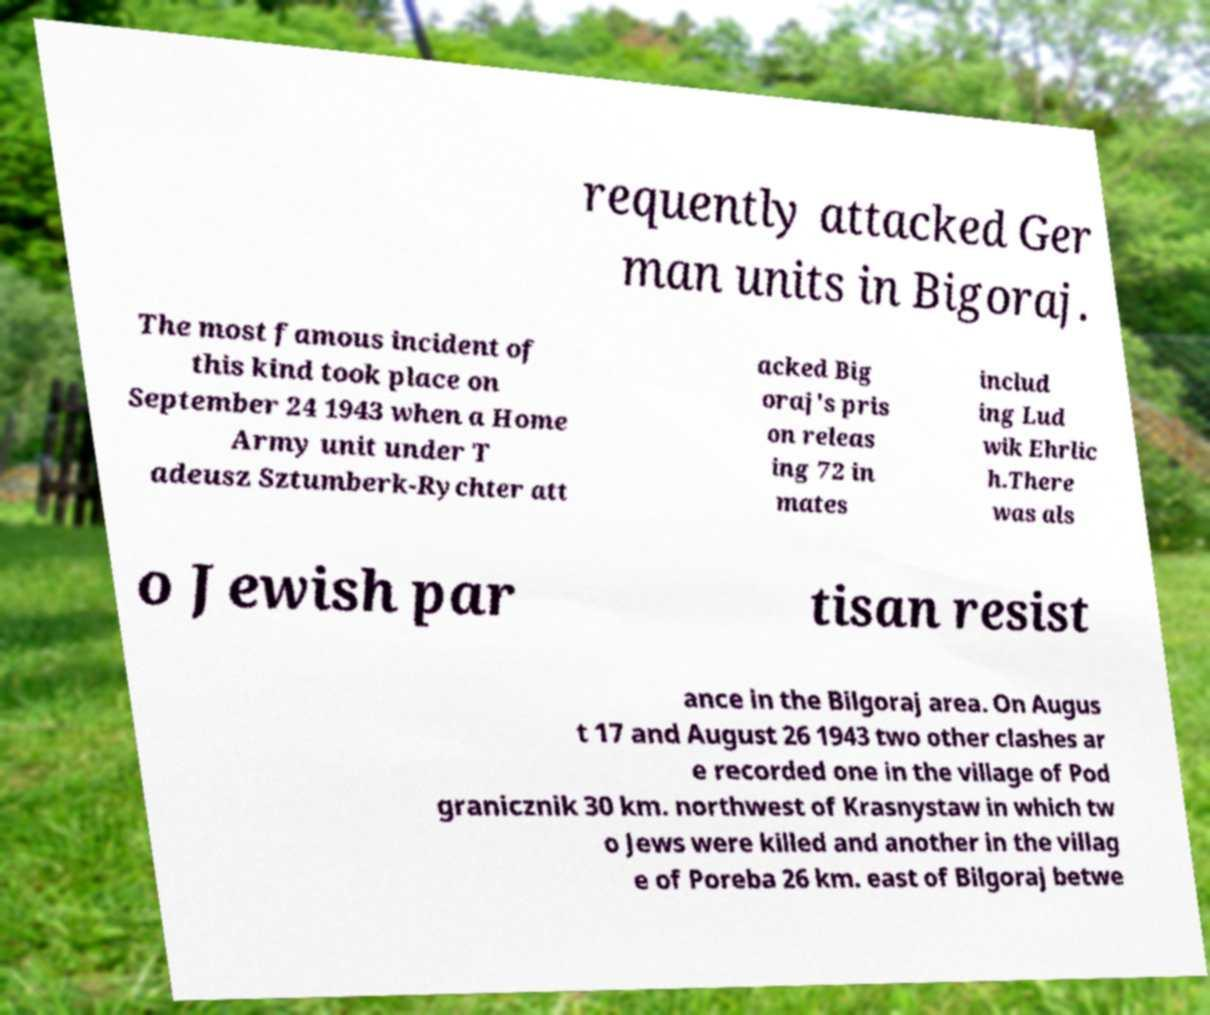Please identify and transcribe the text found in this image. requently attacked Ger man units in Bigoraj. The most famous incident of this kind took place on September 24 1943 when a Home Army unit under T adeusz Sztumberk-Rychter att acked Big oraj's pris on releas ing 72 in mates includ ing Lud wik Ehrlic h.There was als o Jewish par tisan resist ance in the Bilgoraj area. On Augus t 17 and August 26 1943 two other clashes ar e recorded one in the village of Pod granicznik 30 km. northwest of Krasnystaw in which tw o Jews were killed and another in the villag e of Poreba 26 km. east of Bilgoraj betwe 